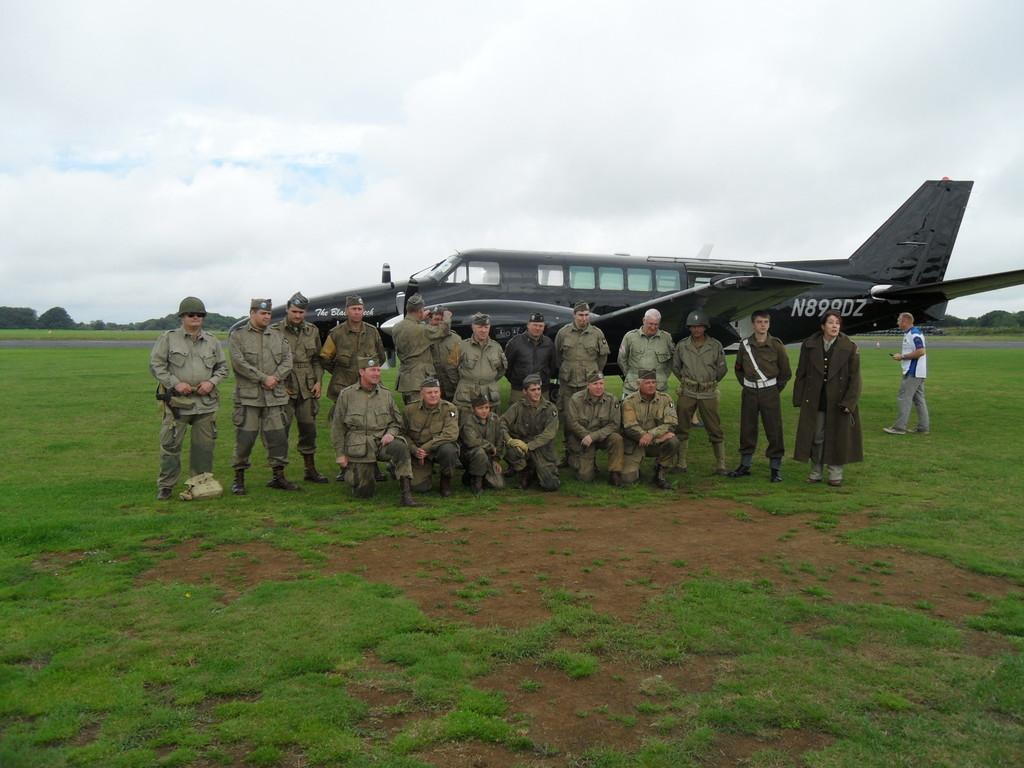What is the code at the very back of the plane?
Your answer should be very brief. N899dz. What is the first letter on the back of the plane?
Provide a short and direct response. N. 